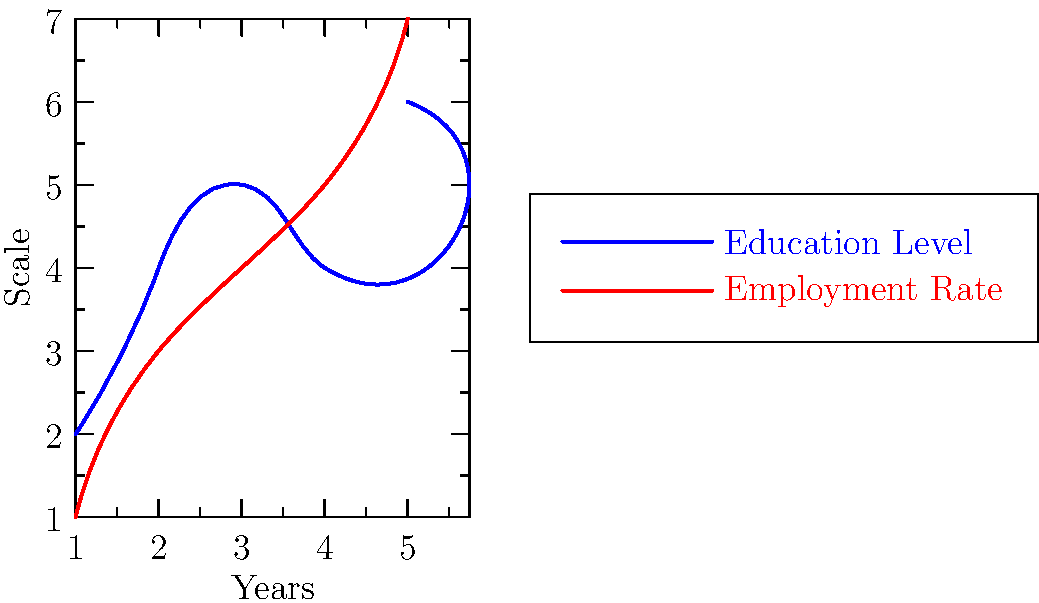Given the graph showing trends in education level and employment rate over 5 years, calculate the dot product of these two social indicators represented as vectors. What does the result suggest about their correlation? To solve this problem, we'll follow these steps:

1) First, we need to represent the education level and employment rate as vectors:
   Education Level: $E = (2, 4, 5, 4, 6)$
   Employment Rate: $R = (1, 3, 4, 5, 7)$

2) The dot product of two vectors $a = (a_1, ..., a_n)$ and $b = (b_1, ..., b_n)$ is defined as:
   $a \cdot b = \sum_{i=1}^n a_i b_i$

3) Let's calculate the dot product:
   $E \cdot R = (2 \times 1) + (4 \times 3) + (5 \times 4) + (4 \times 5) + (6 \times 7)$
              $= 2 + 12 + 20 + 20 + 42$
              $= 96$

4) To interpret this result, we need to compare it to the maximum possible dot product if the vectors were perfectly correlated. The maximum would occur if the vectors were identical (up to a scalar multiple).

5) Let's calculate the magnitudes of the vectors:
   $|E| = \sqrt{2^2 + 4^2 + 5^2 + 4^2 + 6^2} = \sqrt{97} \approx 9.85$
   $|R| = \sqrt{1^2 + 3^2 + 4^2 + 5^2 + 7^2} = \sqrt{100} = 10$

6) The maximum dot product would be $|E| \times |R| \approx 98.5$

7) Our actual dot product (96) is very close to this maximum, suggesting a strong positive correlation between education level and employment rate.
Answer: 96; strong positive correlation 